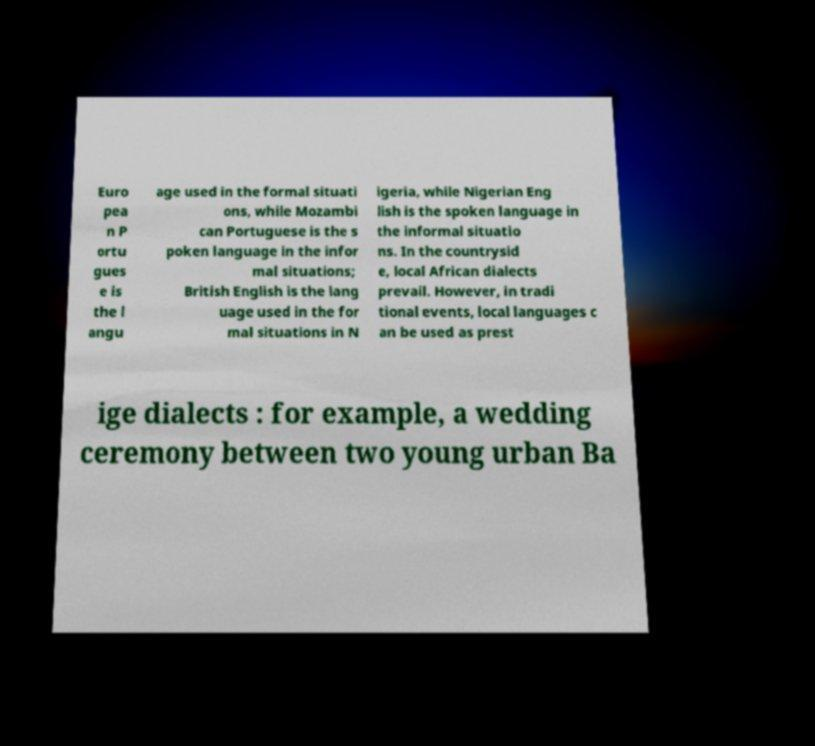There's text embedded in this image that I need extracted. Can you transcribe it verbatim? Euro pea n P ortu gues e is the l angu age used in the formal situati ons, while Mozambi can Portuguese is the s poken language in the infor mal situations; British English is the lang uage used in the for mal situations in N igeria, while Nigerian Eng lish is the spoken language in the informal situatio ns. In the countrysid e, local African dialects prevail. However, in tradi tional events, local languages c an be used as prest ige dialects : for example, a wedding ceremony between two young urban Ba 